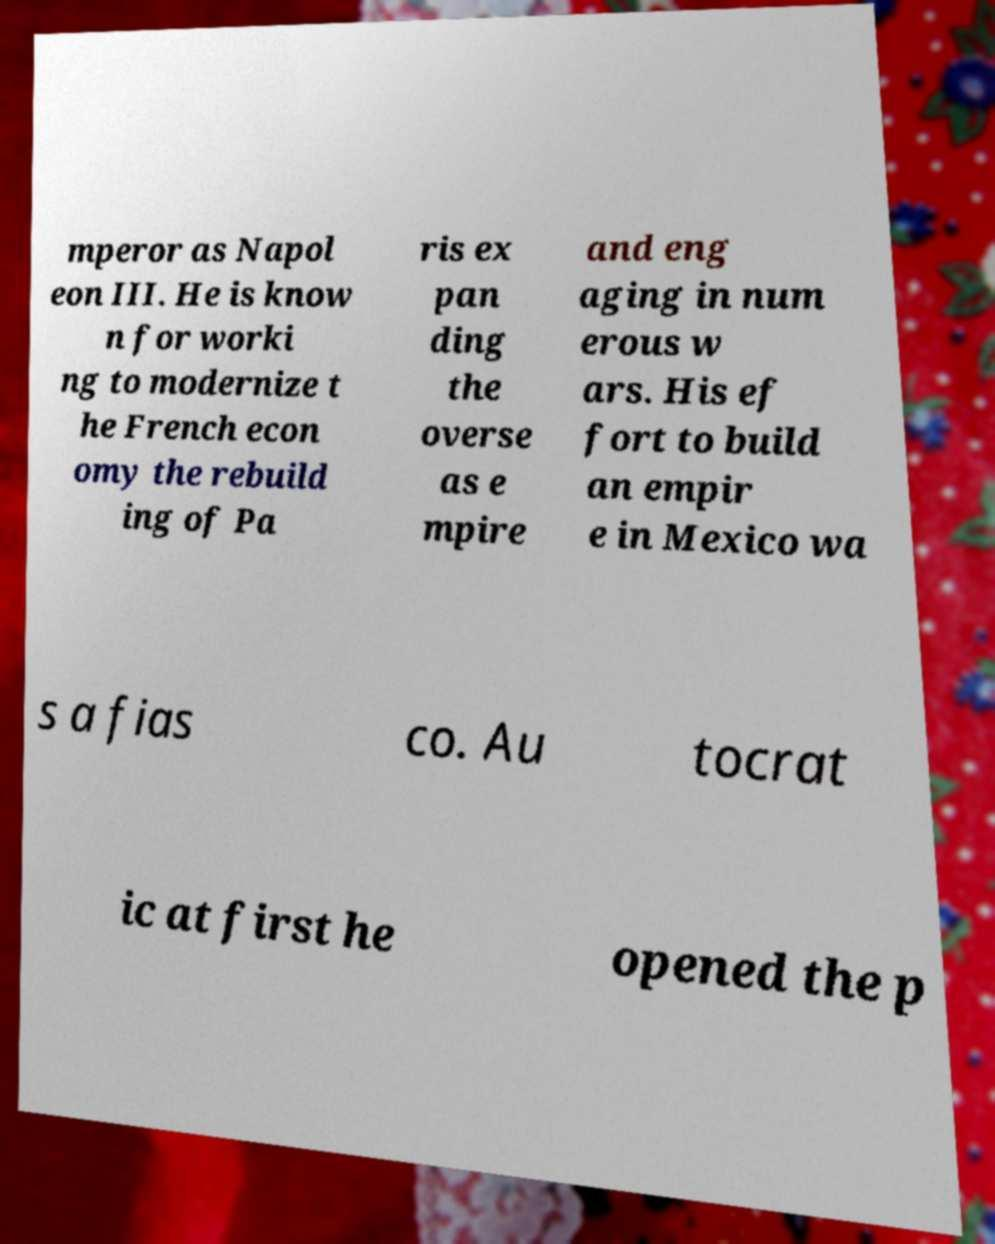There's text embedded in this image that I need extracted. Can you transcribe it verbatim? mperor as Napol eon III. He is know n for worki ng to modernize t he French econ omy the rebuild ing of Pa ris ex pan ding the overse as e mpire and eng aging in num erous w ars. His ef fort to build an empir e in Mexico wa s a fias co. Au tocrat ic at first he opened the p 